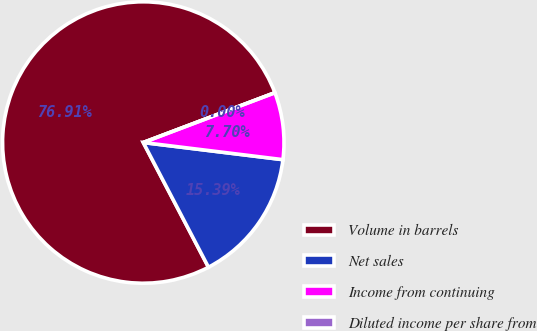Convert chart. <chart><loc_0><loc_0><loc_500><loc_500><pie_chart><fcel>Volume in barrels<fcel>Net sales<fcel>Income from continuing<fcel>Diluted income per share from<nl><fcel>76.91%<fcel>15.39%<fcel>7.7%<fcel>0.0%<nl></chart> 